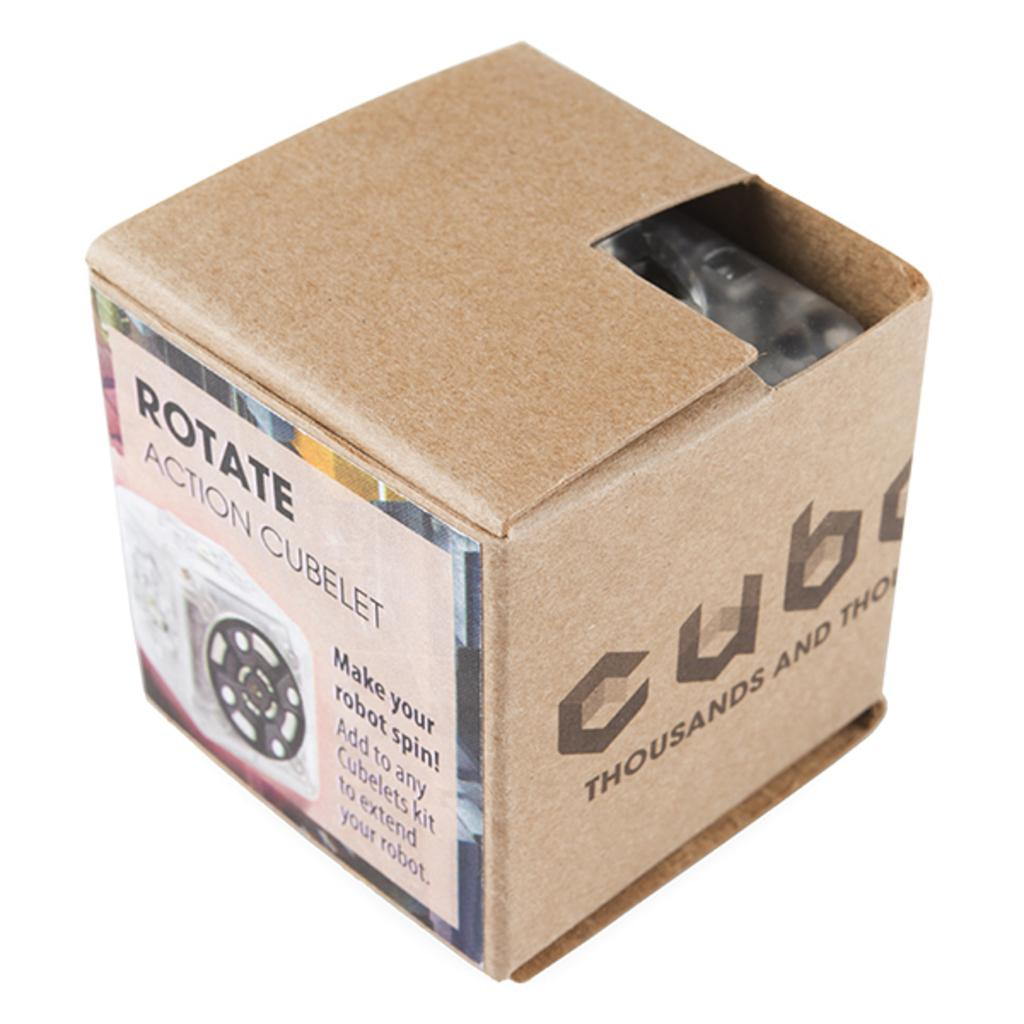<image>
Provide a brief description of the given image. A brown square box with the brand name CUBE. 